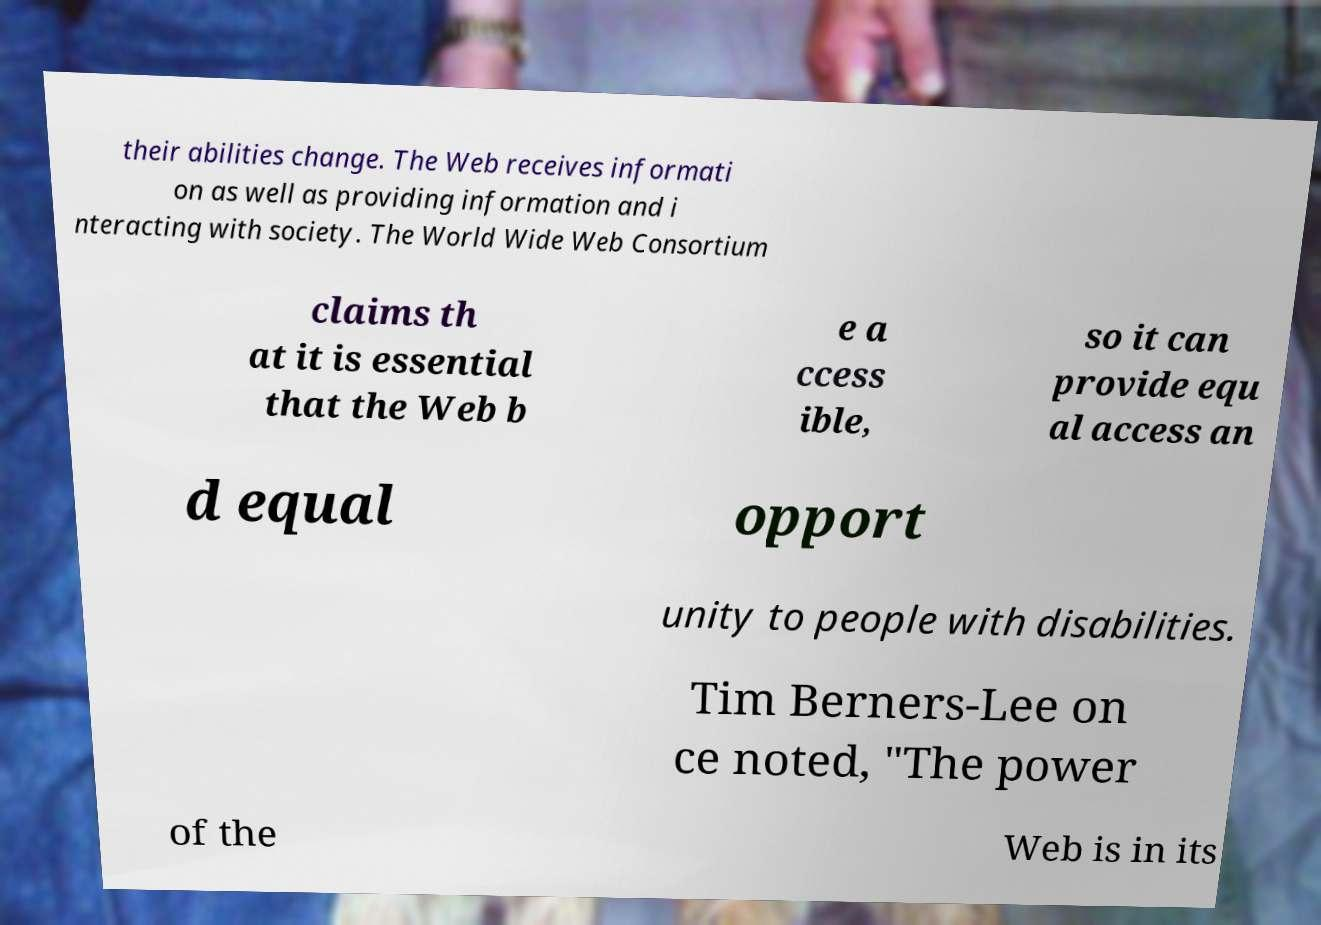Could you assist in decoding the text presented in this image and type it out clearly? their abilities change. The Web receives informati on as well as providing information and i nteracting with society. The World Wide Web Consortium claims th at it is essential that the Web b e a ccess ible, so it can provide equ al access an d equal opport unity to people with disabilities. Tim Berners-Lee on ce noted, "The power of the Web is in its 